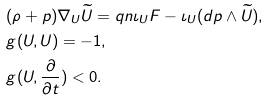Convert formula to latex. <formula><loc_0><loc_0><loc_500><loc_500>& ( \rho + p ) \nabla _ { U } \widetilde { U } = q n \iota _ { U } F - \iota _ { U } ( d p \wedge \widetilde { U } ) , \\ & g ( U , U ) = - 1 , \\ & g ( U , \frac { \partial } { \partial t } ) < 0 .</formula> 